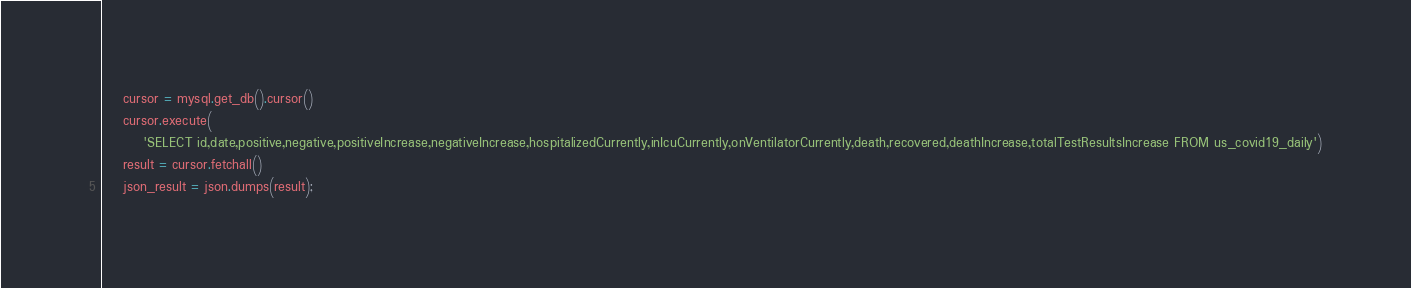<code> <loc_0><loc_0><loc_500><loc_500><_Python_>    cursor = mysql.get_db().cursor()
    cursor.execute(
        'SELECT id,date,positive,negative,positiveIncrease,negativeIncrease,hospitalizedCurrently,inIcuCurrently,onVentilatorCurrently,death,recovered,deathIncrease,totalTestResultsIncrease FROM us_covid19_daily')
    result = cursor.fetchall()
    json_result = json.dumps(result);</code> 